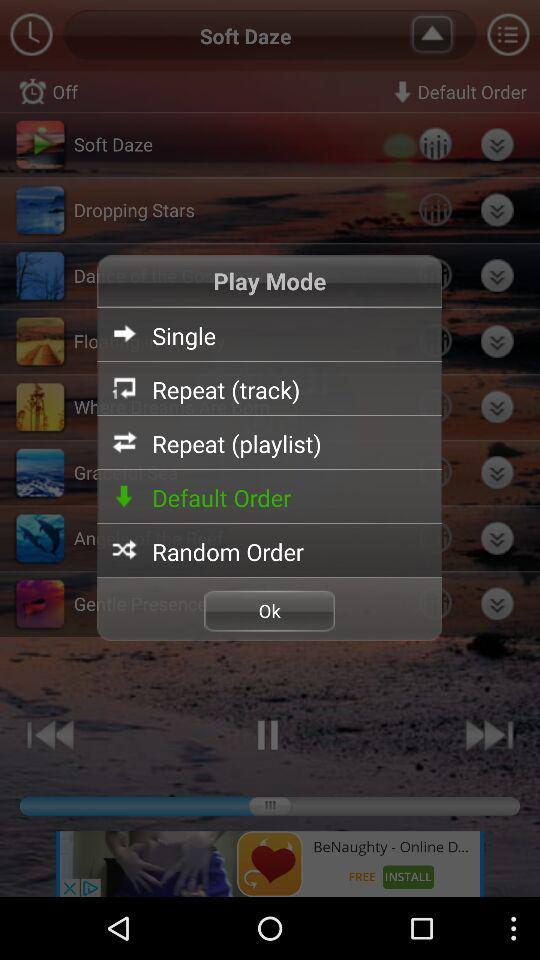Which option is selected? The selected option is "Rowing". 